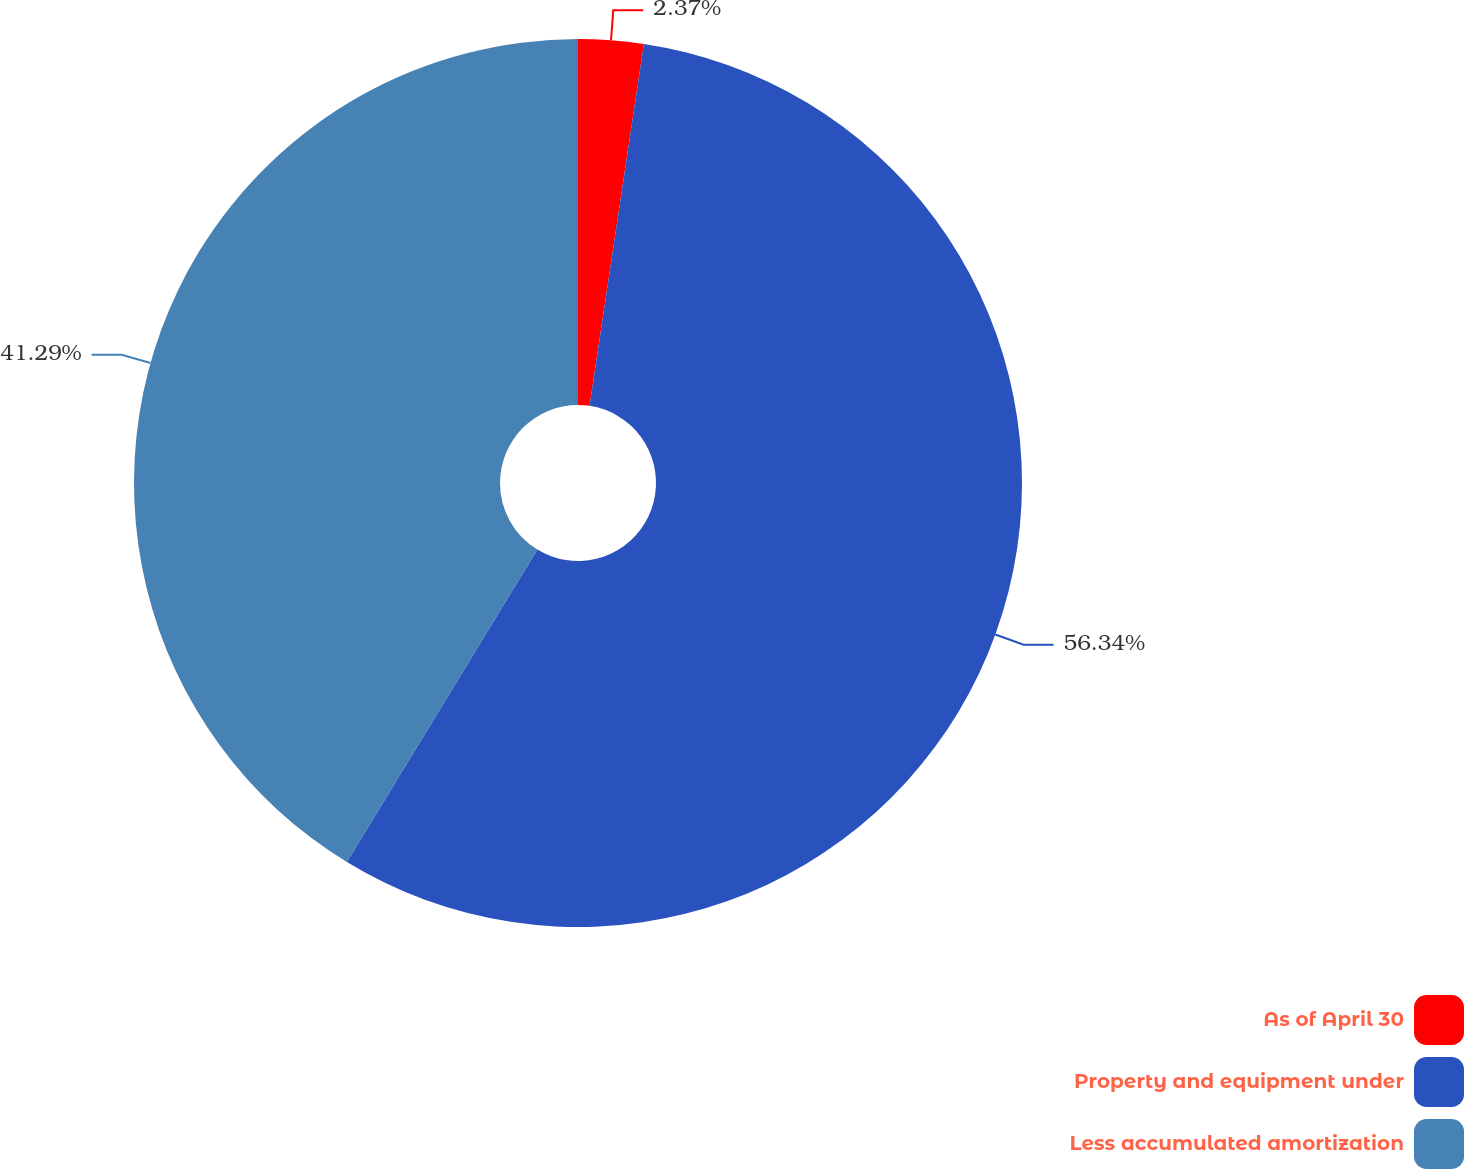Convert chart. <chart><loc_0><loc_0><loc_500><loc_500><pie_chart><fcel>As of April 30<fcel>Property and equipment under<fcel>Less accumulated amortization<nl><fcel>2.37%<fcel>56.35%<fcel>41.29%<nl></chart> 